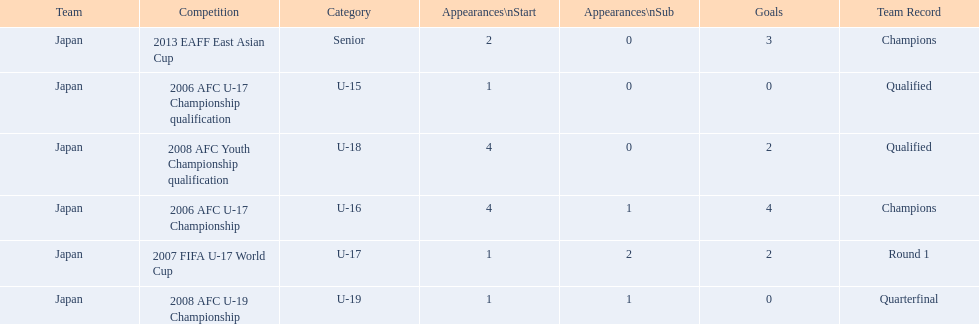How many appearances were there for each competition? 1, 4, 1, 4, 1, 2. How many goals were there for each competition? 0, 4, 2, 2, 0, 3. Which competition(s) has/have the most appearances? 2006 AFC U-17 Championship, 2008 AFC Youth Championship qualification. Which competition(s) has/have the most goals? 2006 AFC U-17 Championship. 